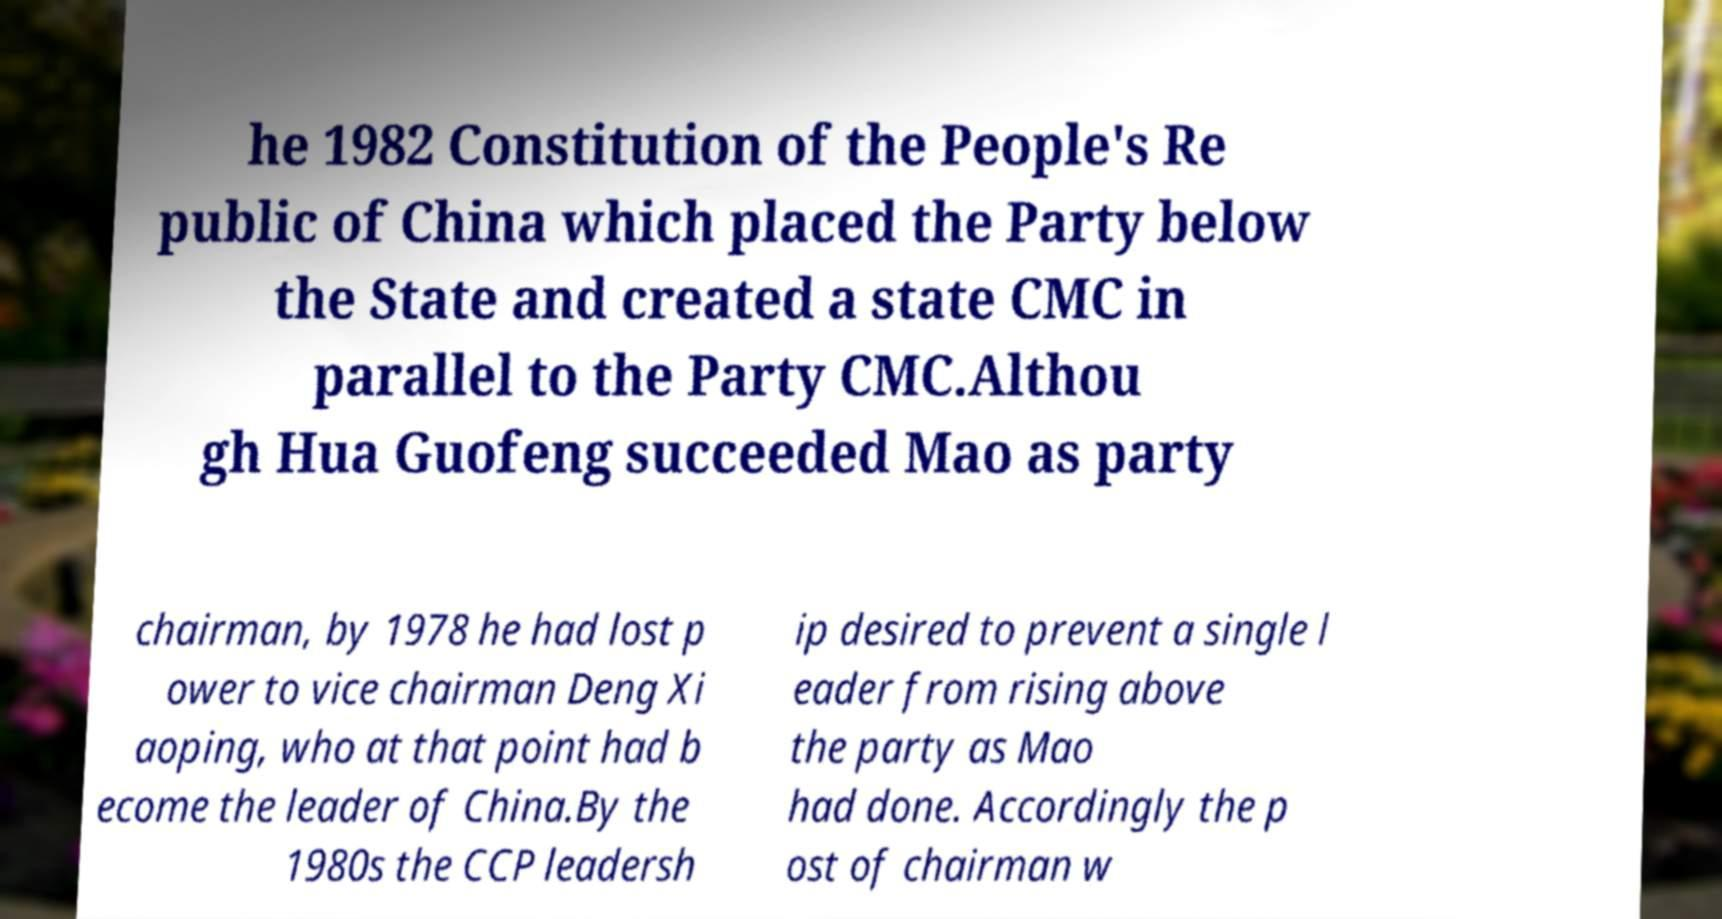Please identify and transcribe the text found in this image. he 1982 Constitution of the People's Re public of China which placed the Party below the State and created a state CMC in parallel to the Party CMC.Althou gh Hua Guofeng succeeded Mao as party chairman, by 1978 he had lost p ower to vice chairman Deng Xi aoping, who at that point had b ecome the leader of China.By the 1980s the CCP leadersh ip desired to prevent a single l eader from rising above the party as Mao had done. Accordingly the p ost of chairman w 